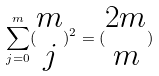<formula> <loc_0><loc_0><loc_500><loc_500>\sum _ { j = 0 } ^ { m } ( \begin{matrix} m \\ j \end{matrix} ) ^ { 2 } = ( \begin{matrix} 2 m \\ m \end{matrix} )</formula> 